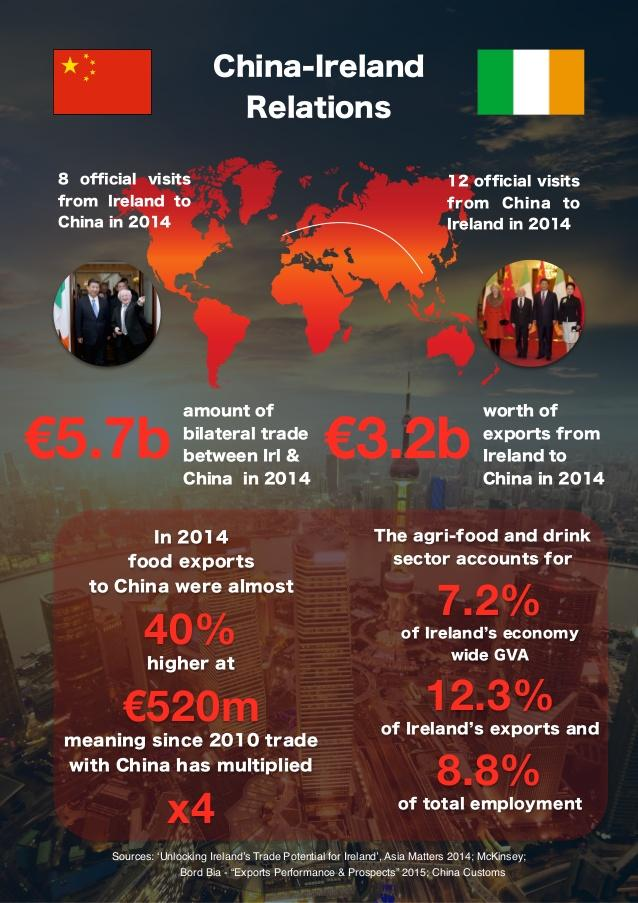Draw attention to some important aspects in this diagram. In 2014, there were 12 official visits from China to Ireland. The increase in food exports to China was 40%. In 2014, there were 8 official visits from Ireland to China. The agri-food and drink sector accounts for 7.2% of the economy. Since 2010, the level of trade between the United States and China has increased fourfold. 